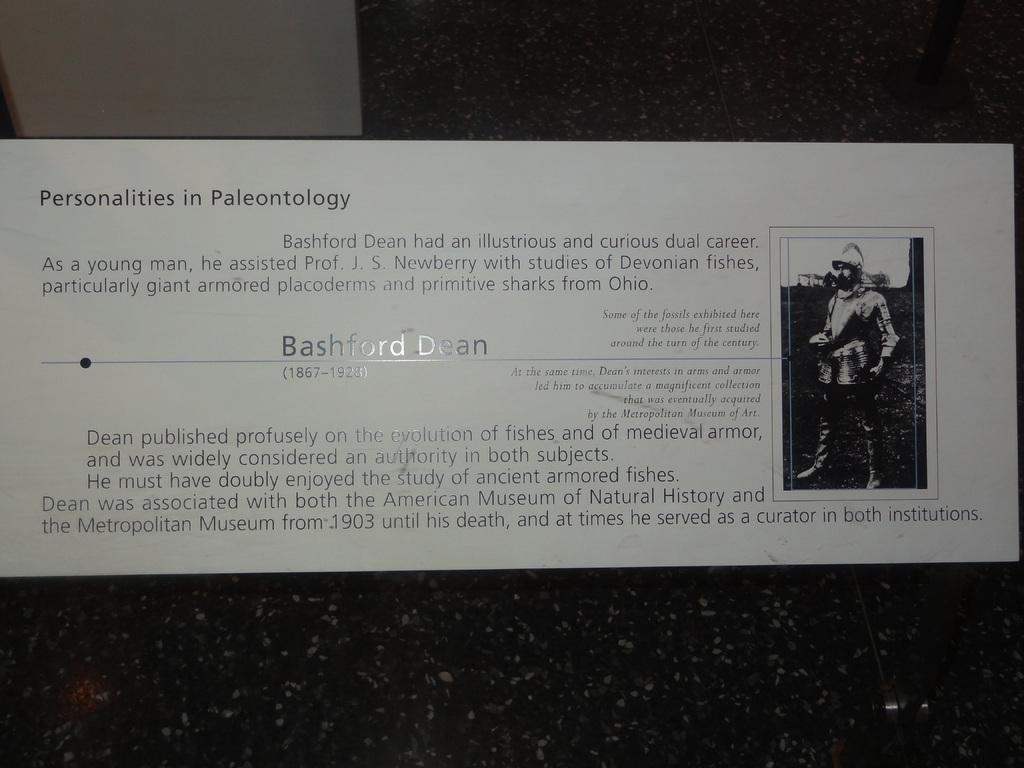Please provide a concise description of this image. In this picture I can see the poster which is placed on the wall. On the right of the poster I can see the man who is standing in front of the mic. 